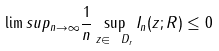Convert formula to latex. <formula><loc_0><loc_0><loc_500><loc_500>\lim s u p _ { n \to \infty } \frac { 1 } { n } \sup _ { z \in \ D _ { r } } I _ { n } ( z ; R ) \leq 0</formula> 